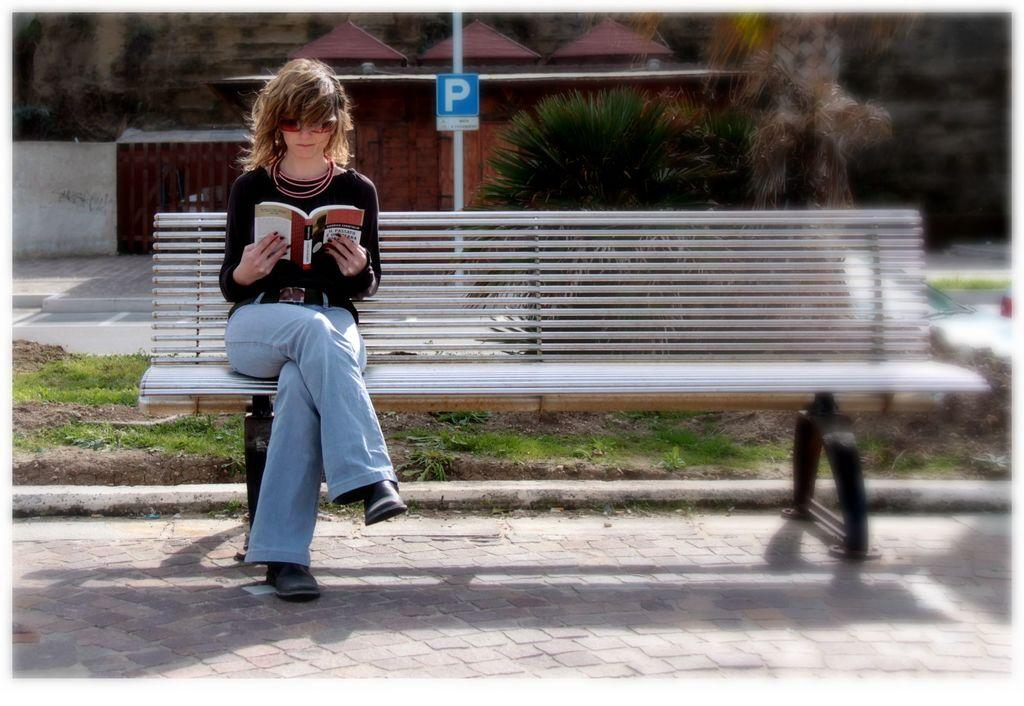Who is the main subject in the image? There is a woman in the image. What is the woman doing in the image? The woman is sitting on a bench and reading a book. What type of clothing is the woman wearing? The woman is wearing a T-shirt and jeans pants. What accessory is the woman wearing on her face? The woman is wearing goggles. What type of chicken can be seen in the image? There is no chicken present in the image. How does the wind affect the woman's reading experience in the image? The image does not show any wind, so it cannot be determined how it would affect the woman's reading experience. 